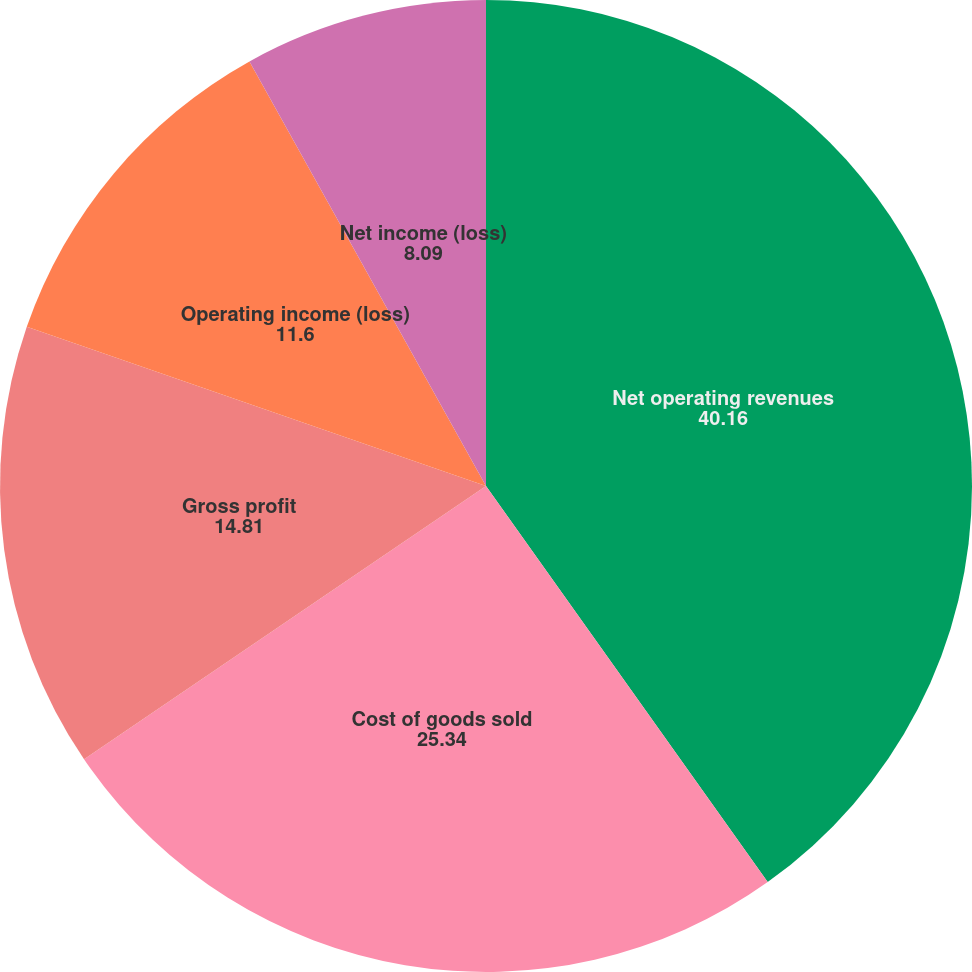Convert chart to OTSL. <chart><loc_0><loc_0><loc_500><loc_500><pie_chart><fcel>Net operating revenues<fcel>Cost of goods sold<fcel>Gross profit<fcel>Operating income (loss)<fcel>Net income (loss)<nl><fcel>40.16%<fcel>25.34%<fcel>14.81%<fcel>11.6%<fcel>8.09%<nl></chart> 